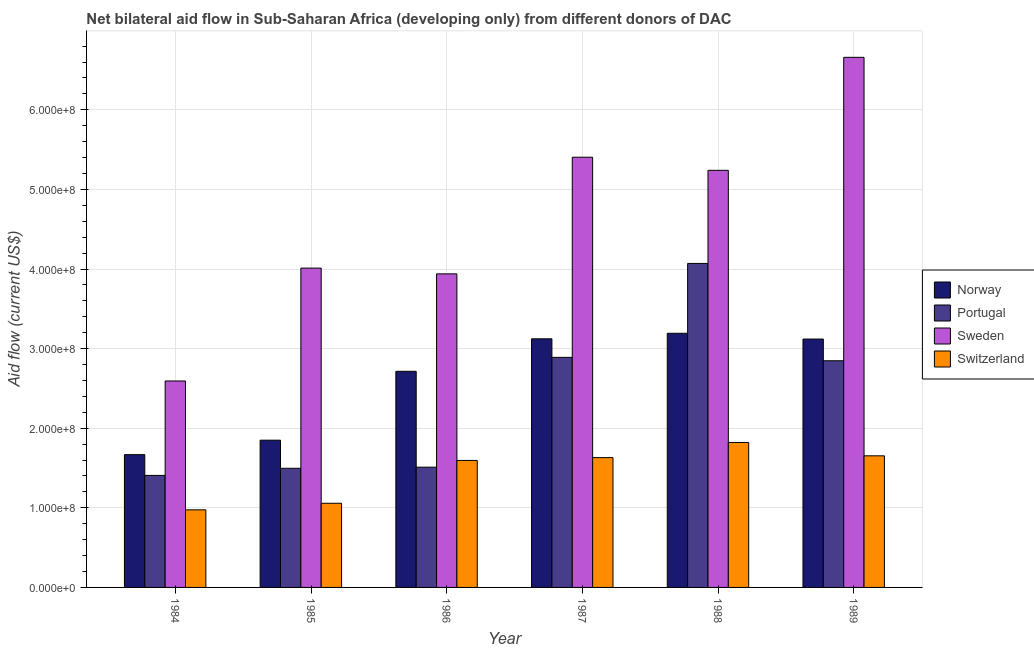How many different coloured bars are there?
Keep it short and to the point. 4. How many groups of bars are there?
Offer a very short reply. 6. Are the number of bars per tick equal to the number of legend labels?
Ensure brevity in your answer.  Yes. Are the number of bars on each tick of the X-axis equal?
Give a very brief answer. Yes. How many bars are there on the 6th tick from the left?
Provide a short and direct response. 4. What is the label of the 1st group of bars from the left?
Offer a very short reply. 1984. What is the amount of aid given by portugal in 1989?
Offer a terse response. 2.85e+08. Across all years, what is the maximum amount of aid given by portugal?
Offer a terse response. 4.07e+08. Across all years, what is the minimum amount of aid given by switzerland?
Your answer should be very brief. 9.75e+07. In which year was the amount of aid given by sweden minimum?
Keep it short and to the point. 1984. What is the total amount of aid given by portugal in the graph?
Ensure brevity in your answer.  1.42e+09. What is the difference between the amount of aid given by portugal in 1984 and that in 1988?
Offer a terse response. -2.66e+08. What is the difference between the amount of aid given by sweden in 1989 and the amount of aid given by switzerland in 1984?
Keep it short and to the point. 4.07e+08. What is the average amount of aid given by switzerland per year?
Provide a short and direct response. 1.46e+08. In the year 1986, what is the difference between the amount of aid given by sweden and amount of aid given by switzerland?
Give a very brief answer. 0. What is the ratio of the amount of aid given by switzerland in 1985 to that in 1988?
Your response must be concise. 0.58. What is the difference between the highest and the second highest amount of aid given by norway?
Make the answer very short. 6.95e+06. What is the difference between the highest and the lowest amount of aid given by norway?
Your answer should be compact. 1.52e+08. In how many years, is the amount of aid given by sweden greater than the average amount of aid given by sweden taken over all years?
Your answer should be compact. 3. Is the sum of the amount of aid given by norway in 1984 and 1989 greater than the maximum amount of aid given by switzerland across all years?
Keep it short and to the point. Yes. Is it the case that in every year, the sum of the amount of aid given by sweden and amount of aid given by portugal is greater than the sum of amount of aid given by norway and amount of aid given by switzerland?
Your answer should be compact. Yes. What does the 4th bar from the left in 1989 represents?
Your answer should be compact. Switzerland. What does the 4th bar from the right in 1988 represents?
Your answer should be compact. Norway. Is it the case that in every year, the sum of the amount of aid given by norway and amount of aid given by portugal is greater than the amount of aid given by sweden?
Your response must be concise. No. Are all the bars in the graph horizontal?
Your answer should be very brief. No. How many years are there in the graph?
Your answer should be very brief. 6. What is the difference between two consecutive major ticks on the Y-axis?
Your answer should be compact. 1.00e+08. Are the values on the major ticks of Y-axis written in scientific E-notation?
Provide a short and direct response. Yes. Does the graph contain any zero values?
Ensure brevity in your answer.  No. Does the graph contain grids?
Keep it short and to the point. Yes. Where does the legend appear in the graph?
Offer a very short reply. Center right. What is the title of the graph?
Provide a succinct answer. Net bilateral aid flow in Sub-Saharan Africa (developing only) from different donors of DAC. What is the label or title of the X-axis?
Provide a succinct answer. Year. What is the label or title of the Y-axis?
Offer a terse response. Aid flow (current US$). What is the Aid flow (current US$) of Norway in 1984?
Your answer should be compact. 1.67e+08. What is the Aid flow (current US$) of Portugal in 1984?
Your answer should be compact. 1.41e+08. What is the Aid flow (current US$) in Sweden in 1984?
Offer a terse response. 2.59e+08. What is the Aid flow (current US$) in Switzerland in 1984?
Your response must be concise. 9.75e+07. What is the Aid flow (current US$) of Norway in 1985?
Your response must be concise. 1.85e+08. What is the Aid flow (current US$) in Portugal in 1985?
Provide a succinct answer. 1.50e+08. What is the Aid flow (current US$) of Sweden in 1985?
Ensure brevity in your answer.  4.01e+08. What is the Aid flow (current US$) in Switzerland in 1985?
Your answer should be very brief. 1.06e+08. What is the Aid flow (current US$) of Norway in 1986?
Give a very brief answer. 2.72e+08. What is the Aid flow (current US$) of Portugal in 1986?
Your answer should be very brief. 1.51e+08. What is the Aid flow (current US$) of Sweden in 1986?
Ensure brevity in your answer.  3.94e+08. What is the Aid flow (current US$) of Switzerland in 1986?
Ensure brevity in your answer.  1.60e+08. What is the Aid flow (current US$) in Norway in 1987?
Ensure brevity in your answer.  3.12e+08. What is the Aid flow (current US$) of Portugal in 1987?
Make the answer very short. 2.89e+08. What is the Aid flow (current US$) in Sweden in 1987?
Offer a terse response. 5.40e+08. What is the Aid flow (current US$) in Switzerland in 1987?
Your answer should be very brief. 1.63e+08. What is the Aid flow (current US$) in Norway in 1988?
Ensure brevity in your answer.  3.19e+08. What is the Aid flow (current US$) of Portugal in 1988?
Your response must be concise. 4.07e+08. What is the Aid flow (current US$) in Sweden in 1988?
Give a very brief answer. 5.24e+08. What is the Aid flow (current US$) of Switzerland in 1988?
Your response must be concise. 1.82e+08. What is the Aid flow (current US$) of Norway in 1989?
Provide a short and direct response. 3.12e+08. What is the Aid flow (current US$) of Portugal in 1989?
Your answer should be very brief. 2.85e+08. What is the Aid flow (current US$) of Sweden in 1989?
Provide a short and direct response. 6.66e+08. What is the Aid flow (current US$) of Switzerland in 1989?
Make the answer very short. 1.65e+08. Across all years, what is the maximum Aid flow (current US$) of Norway?
Provide a succinct answer. 3.19e+08. Across all years, what is the maximum Aid flow (current US$) in Portugal?
Ensure brevity in your answer.  4.07e+08. Across all years, what is the maximum Aid flow (current US$) in Sweden?
Offer a terse response. 6.66e+08. Across all years, what is the maximum Aid flow (current US$) of Switzerland?
Give a very brief answer. 1.82e+08. Across all years, what is the minimum Aid flow (current US$) of Norway?
Provide a succinct answer. 1.67e+08. Across all years, what is the minimum Aid flow (current US$) of Portugal?
Keep it short and to the point. 1.41e+08. Across all years, what is the minimum Aid flow (current US$) of Sweden?
Provide a short and direct response. 2.59e+08. Across all years, what is the minimum Aid flow (current US$) of Switzerland?
Offer a terse response. 9.75e+07. What is the total Aid flow (current US$) in Norway in the graph?
Provide a short and direct response. 1.57e+09. What is the total Aid flow (current US$) in Portugal in the graph?
Offer a very short reply. 1.42e+09. What is the total Aid flow (current US$) of Sweden in the graph?
Keep it short and to the point. 2.78e+09. What is the total Aid flow (current US$) of Switzerland in the graph?
Your answer should be very brief. 8.73e+08. What is the difference between the Aid flow (current US$) in Norway in 1984 and that in 1985?
Offer a very short reply. -1.82e+07. What is the difference between the Aid flow (current US$) of Portugal in 1984 and that in 1985?
Keep it short and to the point. -8.95e+06. What is the difference between the Aid flow (current US$) in Sweden in 1984 and that in 1985?
Your answer should be very brief. -1.42e+08. What is the difference between the Aid flow (current US$) of Switzerland in 1984 and that in 1985?
Keep it short and to the point. -8.23e+06. What is the difference between the Aid flow (current US$) in Norway in 1984 and that in 1986?
Keep it short and to the point. -1.05e+08. What is the difference between the Aid flow (current US$) in Portugal in 1984 and that in 1986?
Ensure brevity in your answer.  -1.04e+07. What is the difference between the Aid flow (current US$) of Sweden in 1984 and that in 1986?
Your response must be concise. -1.35e+08. What is the difference between the Aid flow (current US$) of Switzerland in 1984 and that in 1986?
Offer a terse response. -6.21e+07. What is the difference between the Aid flow (current US$) in Norway in 1984 and that in 1987?
Offer a terse response. -1.45e+08. What is the difference between the Aid flow (current US$) of Portugal in 1984 and that in 1987?
Offer a very short reply. -1.48e+08. What is the difference between the Aid flow (current US$) of Sweden in 1984 and that in 1987?
Offer a terse response. -2.81e+08. What is the difference between the Aid flow (current US$) in Switzerland in 1984 and that in 1987?
Your answer should be very brief. -6.56e+07. What is the difference between the Aid flow (current US$) in Norway in 1984 and that in 1988?
Offer a very short reply. -1.52e+08. What is the difference between the Aid flow (current US$) in Portugal in 1984 and that in 1988?
Ensure brevity in your answer.  -2.66e+08. What is the difference between the Aid flow (current US$) of Sweden in 1984 and that in 1988?
Ensure brevity in your answer.  -2.65e+08. What is the difference between the Aid flow (current US$) of Switzerland in 1984 and that in 1988?
Offer a very short reply. -8.46e+07. What is the difference between the Aid flow (current US$) of Norway in 1984 and that in 1989?
Offer a very short reply. -1.45e+08. What is the difference between the Aid flow (current US$) of Portugal in 1984 and that in 1989?
Offer a very short reply. -1.44e+08. What is the difference between the Aid flow (current US$) in Sweden in 1984 and that in 1989?
Provide a short and direct response. -4.07e+08. What is the difference between the Aid flow (current US$) of Switzerland in 1984 and that in 1989?
Your response must be concise. -6.78e+07. What is the difference between the Aid flow (current US$) of Norway in 1985 and that in 1986?
Offer a terse response. -8.65e+07. What is the difference between the Aid flow (current US$) in Portugal in 1985 and that in 1986?
Keep it short and to the point. -1.40e+06. What is the difference between the Aid flow (current US$) in Sweden in 1985 and that in 1986?
Your answer should be very brief. 7.24e+06. What is the difference between the Aid flow (current US$) in Switzerland in 1985 and that in 1986?
Ensure brevity in your answer.  -5.38e+07. What is the difference between the Aid flow (current US$) of Norway in 1985 and that in 1987?
Give a very brief answer. -1.27e+08. What is the difference between the Aid flow (current US$) in Portugal in 1985 and that in 1987?
Make the answer very short. -1.39e+08. What is the difference between the Aid flow (current US$) in Sweden in 1985 and that in 1987?
Your answer should be very brief. -1.39e+08. What is the difference between the Aid flow (current US$) in Switzerland in 1985 and that in 1987?
Offer a terse response. -5.74e+07. What is the difference between the Aid flow (current US$) of Norway in 1985 and that in 1988?
Offer a terse response. -1.34e+08. What is the difference between the Aid flow (current US$) of Portugal in 1985 and that in 1988?
Your answer should be compact. -2.57e+08. What is the difference between the Aid flow (current US$) in Sweden in 1985 and that in 1988?
Offer a terse response. -1.23e+08. What is the difference between the Aid flow (current US$) of Switzerland in 1985 and that in 1988?
Provide a succinct answer. -7.64e+07. What is the difference between the Aid flow (current US$) in Norway in 1985 and that in 1989?
Your answer should be compact. -1.27e+08. What is the difference between the Aid flow (current US$) in Portugal in 1985 and that in 1989?
Offer a very short reply. -1.35e+08. What is the difference between the Aid flow (current US$) in Sweden in 1985 and that in 1989?
Provide a succinct answer. -2.65e+08. What is the difference between the Aid flow (current US$) of Switzerland in 1985 and that in 1989?
Your answer should be very brief. -5.96e+07. What is the difference between the Aid flow (current US$) in Norway in 1986 and that in 1987?
Your answer should be very brief. -4.08e+07. What is the difference between the Aid flow (current US$) in Portugal in 1986 and that in 1987?
Keep it short and to the point. -1.38e+08. What is the difference between the Aid flow (current US$) of Sweden in 1986 and that in 1987?
Provide a succinct answer. -1.47e+08. What is the difference between the Aid flow (current US$) in Switzerland in 1986 and that in 1987?
Your response must be concise. -3.52e+06. What is the difference between the Aid flow (current US$) in Norway in 1986 and that in 1988?
Your answer should be compact. -4.78e+07. What is the difference between the Aid flow (current US$) in Portugal in 1986 and that in 1988?
Ensure brevity in your answer.  -2.56e+08. What is the difference between the Aid flow (current US$) of Sweden in 1986 and that in 1988?
Your response must be concise. -1.30e+08. What is the difference between the Aid flow (current US$) of Switzerland in 1986 and that in 1988?
Provide a succinct answer. -2.26e+07. What is the difference between the Aid flow (current US$) of Norway in 1986 and that in 1989?
Ensure brevity in your answer.  -4.05e+07. What is the difference between the Aid flow (current US$) in Portugal in 1986 and that in 1989?
Offer a terse response. -1.34e+08. What is the difference between the Aid flow (current US$) of Sweden in 1986 and that in 1989?
Your response must be concise. -2.72e+08. What is the difference between the Aid flow (current US$) of Switzerland in 1986 and that in 1989?
Provide a short and direct response. -5.78e+06. What is the difference between the Aid flow (current US$) in Norway in 1987 and that in 1988?
Offer a very short reply. -6.95e+06. What is the difference between the Aid flow (current US$) in Portugal in 1987 and that in 1988?
Offer a very short reply. -1.18e+08. What is the difference between the Aid flow (current US$) in Sweden in 1987 and that in 1988?
Your answer should be very brief. 1.65e+07. What is the difference between the Aid flow (current US$) of Switzerland in 1987 and that in 1988?
Your response must be concise. -1.90e+07. What is the difference between the Aid flow (current US$) of Norway in 1987 and that in 1989?
Your answer should be compact. 2.90e+05. What is the difference between the Aid flow (current US$) in Portugal in 1987 and that in 1989?
Make the answer very short. 4.27e+06. What is the difference between the Aid flow (current US$) in Sweden in 1987 and that in 1989?
Your answer should be very brief. -1.26e+08. What is the difference between the Aid flow (current US$) of Switzerland in 1987 and that in 1989?
Keep it short and to the point. -2.26e+06. What is the difference between the Aid flow (current US$) of Norway in 1988 and that in 1989?
Provide a succinct answer. 7.24e+06. What is the difference between the Aid flow (current US$) in Portugal in 1988 and that in 1989?
Offer a very short reply. 1.22e+08. What is the difference between the Aid flow (current US$) of Sweden in 1988 and that in 1989?
Make the answer very short. -1.42e+08. What is the difference between the Aid flow (current US$) of Switzerland in 1988 and that in 1989?
Give a very brief answer. 1.68e+07. What is the difference between the Aid flow (current US$) in Norway in 1984 and the Aid flow (current US$) in Portugal in 1985?
Your response must be concise. 1.72e+07. What is the difference between the Aid flow (current US$) of Norway in 1984 and the Aid flow (current US$) of Sweden in 1985?
Your answer should be very brief. -2.34e+08. What is the difference between the Aid flow (current US$) in Norway in 1984 and the Aid flow (current US$) in Switzerland in 1985?
Make the answer very short. 6.11e+07. What is the difference between the Aid flow (current US$) in Portugal in 1984 and the Aid flow (current US$) in Sweden in 1985?
Provide a short and direct response. -2.60e+08. What is the difference between the Aid flow (current US$) of Portugal in 1984 and the Aid flow (current US$) of Switzerland in 1985?
Provide a short and direct response. 3.50e+07. What is the difference between the Aid flow (current US$) of Sweden in 1984 and the Aid flow (current US$) of Switzerland in 1985?
Your answer should be very brief. 1.54e+08. What is the difference between the Aid flow (current US$) of Norway in 1984 and the Aid flow (current US$) of Portugal in 1986?
Give a very brief answer. 1.58e+07. What is the difference between the Aid flow (current US$) in Norway in 1984 and the Aid flow (current US$) in Sweden in 1986?
Give a very brief answer. -2.27e+08. What is the difference between the Aid flow (current US$) in Norway in 1984 and the Aid flow (current US$) in Switzerland in 1986?
Ensure brevity in your answer.  7.28e+06. What is the difference between the Aid flow (current US$) in Portugal in 1984 and the Aid flow (current US$) in Sweden in 1986?
Your answer should be compact. -2.53e+08. What is the difference between the Aid flow (current US$) in Portugal in 1984 and the Aid flow (current US$) in Switzerland in 1986?
Your answer should be very brief. -1.88e+07. What is the difference between the Aid flow (current US$) in Sweden in 1984 and the Aid flow (current US$) in Switzerland in 1986?
Provide a short and direct response. 9.98e+07. What is the difference between the Aid flow (current US$) in Norway in 1984 and the Aid flow (current US$) in Portugal in 1987?
Offer a very short reply. -1.22e+08. What is the difference between the Aid flow (current US$) of Norway in 1984 and the Aid flow (current US$) of Sweden in 1987?
Keep it short and to the point. -3.74e+08. What is the difference between the Aid flow (current US$) in Norway in 1984 and the Aid flow (current US$) in Switzerland in 1987?
Provide a short and direct response. 3.76e+06. What is the difference between the Aid flow (current US$) of Portugal in 1984 and the Aid flow (current US$) of Sweden in 1987?
Keep it short and to the point. -4.00e+08. What is the difference between the Aid flow (current US$) of Portugal in 1984 and the Aid flow (current US$) of Switzerland in 1987?
Your answer should be compact. -2.24e+07. What is the difference between the Aid flow (current US$) of Sweden in 1984 and the Aid flow (current US$) of Switzerland in 1987?
Provide a succinct answer. 9.63e+07. What is the difference between the Aid flow (current US$) of Norway in 1984 and the Aid flow (current US$) of Portugal in 1988?
Your answer should be very brief. -2.40e+08. What is the difference between the Aid flow (current US$) in Norway in 1984 and the Aid flow (current US$) in Sweden in 1988?
Give a very brief answer. -3.57e+08. What is the difference between the Aid flow (current US$) of Norway in 1984 and the Aid flow (current US$) of Switzerland in 1988?
Offer a terse response. -1.53e+07. What is the difference between the Aid flow (current US$) of Portugal in 1984 and the Aid flow (current US$) of Sweden in 1988?
Offer a very short reply. -3.83e+08. What is the difference between the Aid flow (current US$) of Portugal in 1984 and the Aid flow (current US$) of Switzerland in 1988?
Make the answer very short. -4.14e+07. What is the difference between the Aid flow (current US$) of Sweden in 1984 and the Aid flow (current US$) of Switzerland in 1988?
Give a very brief answer. 7.72e+07. What is the difference between the Aid flow (current US$) of Norway in 1984 and the Aid flow (current US$) of Portugal in 1989?
Offer a very short reply. -1.18e+08. What is the difference between the Aid flow (current US$) of Norway in 1984 and the Aid flow (current US$) of Sweden in 1989?
Ensure brevity in your answer.  -4.99e+08. What is the difference between the Aid flow (current US$) of Norway in 1984 and the Aid flow (current US$) of Switzerland in 1989?
Offer a very short reply. 1.50e+06. What is the difference between the Aid flow (current US$) of Portugal in 1984 and the Aid flow (current US$) of Sweden in 1989?
Your response must be concise. -5.25e+08. What is the difference between the Aid flow (current US$) of Portugal in 1984 and the Aid flow (current US$) of Switzerland in 1989?
Offer a terse response. -2.46e+07. What is the difference between the Aid flow (current US$) of Sweden in 1984 and the Aid flow (current US$) of Switzerland in 1989?
Your response must be concise. 9.40e+07. What is the difference between the Aid flow (current US$) of Norway in 1985 and the Aid flow (current US$) of Portugal in 1986?
Your answer should be very brief. 3.39e+07. What is the difference between the Aid flow (current US$) in Norway in 1985 and the Aid flow (current US$) in Sweden in 1986?
Ensure brevity in your answer.  -2.09e+08. What is the difference between the Aid flow (current US$) of Norway in 1985 and the Aid flow (current US$) of Switzerland in 1986?
Your answer should be very brief. 2.54e+07. What is the difference between the Aid flow (current US$) in Portugal in 1985 and the Aid flow (current US$) in Sweden in 1986?
Offer a terse response. -2.44e+08. What is the difference between the Aid flow (current US$) of Portugal in 1985 and the Aid flow (current US$) of Switzerland in 1986?
Your answer should be compact. -9.88e+06. What is the difference between the Aid flow (current US$) of Sweden in 1985 and the Aid flow (current US$) of Switzerland in 1986?
Give a very brief answer. 2.42e+08. What is the difference between the Aid flow (current US$) in Norway in 1985 and the Aid flow (current US$) in Portugal in 1987?
Ensure brevity in your answer.  -1.04e+08. What is the difference between the Aid flow (current US$) of Norway in 1985 and the Aid flow (current US$) of Sweden in 1987?
Your answer should be very brief. -3.55e+08. What is the difference between the Aid flow (current US$) of Norway in 1985 and the Aid flow (current US$) of Switzerland in 1987?
Your response must be concise. 2.19e+07. What is the difference between the Aid flow (current US$) in Portugal in 1985 and the Aid flow (current US$) in Sweden in 1987?
Offer a very short reply. -3.91e+08. What is the difference between the Aid flow (current US$) of Portugal in 1985 and the Aid flow (current US$) of Switzerland in 1987?
Your response must be concise. -1.34e+07. What is the difference between the Aid flow (current US$) in Sweden in 1985 and the Aid flow (current US$) in Switzerland in 1987?
Ensure brevity in your answer.  2.38e+08. What is the difference between the Aid flow (current US$) of Norway in 1985 and the Aid flow (current US$) of Portugal in 1988?
Provide a short and direct response. -2.22e+08. What is the difference between the Aid flow (current US$) of Norway in 1985 and the Aid flow (current US$) of Sweden in 1988?
Your answer should be very brief. -3.39e+08. What is the difference between the Aid flow (current US$) of Norway in 1985 and the Aid flow (current US$) of Switzerland in 1988?
Your answer should be very brief. 2.89e+06. What is the difference between the Aid flow (current US$) of Portugal in 1985 and the Aid flow (current US$) of Sweden in 1988?
Your answer should be very brief. -3.74e+08. What is the difference between the Aid flow (current US$) in Portugal in 1985 and the Aid flow (current US$) in Switzerland in 1988?
Provide a short and direct response. -3.24e+07. What is the difference between the Aid flow (current US$) in Sweden in 1985 and the Aid flow (current US$) in Switzerland in 1988?
Keep it short and to the point. 2.19e+08. What is the difference between the Aid flow (current US$) of Norway in 1985 and the Aid flow (current US$) of Portugal in 1989?
Ensure brevity in your answer.  -9.98e+07. What is the difference between the Aid flow (current US$) of Norway in 1985 and the Aid flow (current US$) of Sweden in 1989?
Provide a succinct answer. -4.81e+08. What is the difference between the Aid flow (current US$) in Norway in 1985 and the Aid flow (current US$) in Switzerland in 1989?
Ensure brevity in your answer.  1.97e+07. What is the difference between the Aid flow (current US$) of Portugal in 1985 and the Aid flow (current US$) of Sweden in 1989?
Offer a terse response. -5.16e+08. What is the difference between the Aid flow (current US$) in Portugal in 1985 and the Aid flow (current US$) in Switzerland in 1989?
Your answer should be very brief. -1.57e+07. What is the difference between the Aid flow (current US$) in Sweden in 1985 and the Aid flow (current US$) in Switzerland in 1989?
Your answer should be compact. 2.36e+08. What is the difference between the Aid flow (current US$) in Norway in 1986 and the Aid flow (current US$) in Portugal in 1987?
Ensure brevity in your answer.  -1.75e+07. What is the difference between the Aid flow (current US$) of Norway in 1986 and the Aid flow (current US$) of Sweden in 1987?
Keep it short and to the point. -2.69e+08. What is the difference between the Aid flow (current US$) in Norway in 1986 and the Aid flow (current US$) in Switzerland in 1987?
Ensure brevity in your answer.  1.08e+08. What is the difference between the Aid flow (current US$) in Portugal in 1986 and the Aid flow (current US$) in Sweden in 1987?
Your answer should be very brief. -3.89e+08. What is the difference between the Aid flow (current US$) of Portugal in 1986 and the Aid flow (current US$) of Switzerland in 1987?
Your response must be concise. -1.20e+07. What is the difference between the Aid flow (current US$) in Sweden in 1986 and the Aid flow (current US$) in Switzerland in 1987?
Make the answer very short. 2.31e+08. What is the difference between the Aid flow (current US$) in Norway in 1986 and the Aid flow (current US$) in Portugal in 1988?
Keep it short and to the point. -1.36e+08. What is the difference between the Aid flow (current US$) in Norway in 1986 and the Aid flow (current US$) in Sweden in 1988?
Provide a succinct answer. -2.52e+08. What is the difference between the Aid flow (current US$) in Norway in 1986 and the Aid flow (current US$) in Switzerland in 1988?
Make the answer very short. 8.94e+07. What is the difference between the Aid flow (current US$) of Portugal in 1986 and the Aid flow (current US$) of Sweden in 1988?
Your answer should be very brief. -3.73e+08. What is the difference between the Aid flow (current US$) in Portugal in 1986 and the Aid flow (current US$) in Switzerland in 1988?
Keep it short and to the point. -3.10e+07. What is the difference between the Aid flow (current US$) in Sweden in 1986 and the Aid flow (current US$) in Switzerland in 1988?
Provide a short and direct response. 2.12e+08. What is the difference between the Aid flow (current US$) of Norway in 1986 and the Aid flow (current US$) of Portugal in 1989?
Your answer should be compact. -1.32e+07. What is the difference between the Aid flow (current US$) in Norway in 1986 and the Aid flow (current US$) in Sweden in 1989?
Offer a very short reply. -3.94e+08. What is the difference between the Aid flow (current US$) in Norway in 1986 and the Aid flow (current US$) in Switzerland in 1989?
Offer a very short reply. 1.06e+08. What is the difference between the Aid flow (current US$) in Portugal in 1986 and the Aid flow (current US$) in Sweden in 1989?
Your answer should be compact. -5.15e+08. What is the difference between the Aid flow (current US$) in Portugal in 1986 and the Aid flow (current US$) in Switzerland in 1989?
Ensure brevity in your answer.  -1.43e+07. What is the difference between the Aid flow (current US$) of Sweden in 1986 and the Aid flow (current US$) of Switzerland in 1989?
Offer a very short reply. 2.29e+08. What is the difference between the Aid flow (current US$) of Norway in 1987 and the Aid flow (current US$) of Portugal in 1988?
Offer a terse response. -9.47e+07. What is the difference between the Aid flow (current US$) of Norway in 1987 and the Aid flow (current US$) of Sweden in 1988?
Give a very brief answer. -2.12e+08. What is the difference between the Aid flow (current US$) in Norway in 1987 and the Aid flow (current US$) in Switzerland in 1988?
Provide a succinct answer. 1.30e+08. What is the difference between the Aid flow (current US$) in Portugal in 1987 and the Aid flow (current US$) in Sweden in 1988?
Your answer should be very brief. -2.35e+08. What is the difference between the Aid flow (current US$) in Portugal in 1987 and the Aid flow (current US$) in Switzerland in 1988?
Offer a very short reply. 1.07e+08. What is the difference between the Aid flow (current US$) of Sweden in 1987 and the Aid flow (current US$) of Switzerland in 1988?
Provide a succinct answer. 3.58e+08. What is the difference between the Aid flow (current US$) in Norway in 1987 and the Aid flow (current US$) in Portugal in 1989?
Your answer should be very brief. 2.76e+07. What is the difference between the Aid flow (current US$) of Norway in 1987 and the Aid flow (current US$) of Sweden in 1989?
Your answer should be very brief. -3.54e+08. What is the difference between the Aid flow (current US$) of Norway in 1987 and the Aid flow (current US$) of Switzerland in 1989?
Offer a very short reply. 1.47e+08. What is the difference between the Aid flow (current US$) in Portugal in 1987 and the Aid flow (current US$) in Sweden in 1989?
Provide a short and direct response. -3.77e+08. What is the difference between the Aid flow (current US$) of Portugal in 1987 and the Aid flow (current US$) of Switzerland in 1989?
Provide a short and direct response. 1.24e+08. What is the difference between the Aid flow (current US$) in Sweden in 1987 and the Aid flow (current US$) in Switzerland in 1989?
Give a very brief answer. 3.75e+08. What is the difference between the Aid flow (current US$) in Norway in 1988 and the Aid flow (current US$) in Portugal in 1989?
Give a very brief answer. 3.45e+07. What is the difference between the Aid flow (current US$) in Norway in 1988 and the Aid flow (current US$) in Sweden in 1989?
Offer a terse response. -3.47e+08. What is the difference between the Aid flow (current US$) in Norway in 1988 and the Aid flow (current US$) in Switzerland in 1989?
Offer a very short reply. 1.54e+08. What is the difference between the Aid flow (current US$) in Portugal in 1988 and the Aid flow (current US$) in Sweden in 1989?
Offer a very short reply. -2.59e+08. What is the difference between the Aid flow (current US$) in Portugal in 1988 and the Aid flow (current US$) in Switzerland in 1989?
Give a very brief answer. 2.42e+08. What is the difference between the Aid flow (current US$) in Sweden in 1988 and the Aid flow (current US$) in Switzerland in 1989?
Keep it short and to the point. 3.59e+08. What is the average Aid flow (current US$) of Norway per year?
Provide a short and direct response. 2.61e+08. What is the average Aid flow (current US$) of Portugal per year?
Keep it short and to the point. 2.37e+08. What is the average Aid flow (current US$) in Sweden per year?
Give a very brief answer. 4.64e+08. What is the average Aid flow (current US$) of Switzerland per year?
Offer a very short reply. 1.46e+08. In the year 1984, what is the difference between the Aid flow (current US$) of Norway and Aid flow (current US$) of Portugal?
Offer a very short reply. 2.61e+07. In the year 1984, what is the difference between the Aid flow (current US$) in Norway and Aid flow (current US$) in Sweden?
Make the answer very short. -9.25e+07. In the year 1984, what is the difference between the Aid flow (current US$) in Norway and Aid flow (current US$) in Switzerland?
Ensure brevity in your answer.  6.94e+07. In the year 1984, what is the difference between the Aid flow (current US$) in Portugal and Aid flow (current US$) in Sweden?
Provide a short and direct response. -1.19e+08. In the year 1984, what is the difference between the Aid flow (current US$) of Portugal and Aid flow (current US$) of Switzerland?
Keep it short and to the point. 4.32e+07. In the year 1984, what is the difference between the Aid flow (current US$) in Sweden and Aid flow (current US$) in Switzerland?
Keep it short and to the point. 1.62e+08. In the year 1985, what is the difference between the Aid flow (current US$) of Norway and Aid flow (current US$) of Portugal?
Provide a succinct answer. 3.53e+07. In the year 1985, what is the difference between the Aid flow (current US$) of Norway and Aid flow (current US$) of Sweden?
Provide a short and direct response. -2.16e+08. In the year 1985, what is the difference between the Aid flow (current US$) of Norway and Aid flow (current US$) of Switzerland?
Provide a short and direct response. 7.93e+07. In the year 1985, what is the difference between the Aid flow (current US$) of Portugal and Aid flow (current US$) of Sweden?
Offer a very short reply. -2.51e+08. In the year 1985, what is the difference between the Aid flow (current US$) in Portugal and Aid flow (current US$) in Switzerland?
Your response must be concise. 4.40e+07. In the year 1985, what is the difference between the Aid flow (current US$) in Sweden and Aid flow (current US$) in Switzerland?
Keep it short and to the point. 2.95e+08. In the year 1986, what is the difference between the Aid flow (current US$) of Norway and Aid flow (current US$) of Portugal?
Make the answer very short. 1.20e+08. In the year 1986, what is the difference between the Aid flow (current US$) of Norway and Aid flow (current US$) of Sweden?
Provide a succinct answer. -1.22e+08. In the year 1986, what is the difference between the Aid flow (current US$) in Norway and Aid flow (current US$) in Switzerland?
Ensure brevity in your answer.  1.12e+08. In the year 1986, what is the difference between the Aid flow (current US$) in Portugal and Aid flow (current US$) in Sweden?
Keep it short and to the point. -2.43e+08. In the year 1986, what is the difference between the Aid flow (current US$) in Portugal and Aid flow (current US$) in Switzerland?
Your response must be concise. -8.48e+06. In the year 1986, what is the difference between the Aid flow (current US$) in Sweden and Aid flow (current US$) in Switzerland?
Your answer should be very brief. 2.34e+08. In the year 1987, what is the difference between the Aid flow (current US$) in Norway and Aid flow (current US$) in Portugal?
Offer a terse response. 2.33e+07. In the year 1987, what is the difference between the Aid flow (current US$) of Norway and Aid flow (current US$) of Sweden?
Your answer should be very brief. -2.28e+08. In the year 1987, what is the difference between the Aid flow (current US$) in Norway and Aid flow (current US$) in Switzerland?
Ensure brevity in your answer.  1.49e+08. In the year 1987, what is the difference between the Aid flow (current US$) of Portugal and Aid flow (current US$) of Sweden?
Give a very brief answer. -2.51e+08. In the year 1987, what is the difference between the Aid flow (current US$) in Portugal and Aid flow (current US$) in Switzerland?
Offer a very short reply. 1.26e+08. In the year 1987, what is the difference between the Aid flow (current US$) in Sweden and Aid flow (current US$) in Switzerland?
Your answer should be compact. 3.77e+08. In the year 1988, what is the difference between the Aid flow (current US$) of Norway and Aid flow (current US$) of Portugal?
Offer a terse response. -8.78e+07. In the year 1988, what is the difference between the Aid flow (current US$) in Norway and Aid flow (current US$) in Sweden?
Offer a terse response. -2.05e+08. In the year 1988, what is the difference between the Aid flow (current US$) in Norway and Aid flow (current US$) in Switzerland?
Ensure brevity in your answer.  1.37e+08. In the year 1988, what is the difference between the Aid flow (current US$) of Portugal and Aid flow (current US$) of Sweden?
Give a very brief answer. -1.17e+08. In the year 1988, what is the difference between the Aid flow (current US$) in Portugal and Aid flow (current US$) in Switzerland?
Give a very brief answer. 2.25e+08. In the year 1988, what is the difference between the Aid flow (current US$) of Sweden and Aid flow (current US$) of Switzerland?
Your answer should be compact. 3.42e+08. In the year 1989, what is the difference between the Aid flow (current US$) of Norway and Aid flow (current US$) of Portugal?
Your response must be concise. 2.73e+07. In the year 1989, what is the difference between the Aid flow (current US$) in Norway and Aid flow (current US$) in Sweden?
Your answer should be very brief. -3.54e+08. In the year 1989, what is the difference between the Aid flow (current US$) in Norway and Aid flow (current US$) in Switzerland?
Provide a short and direct response. 1.47e+08. In the year 1989, what is the difference between the Aid flow (current US$) of Portugal and Aid flow (current US$) of Sweden?
Offer a terse response. -3.81e+08. In the year 1989, what is the difference between the Aid flow (current US$) of Portugal and Aid flow (current US$) of Switzerland?
Keep it short and to the point. 1.19e+08. In the year 1989, what is the difference between the Aid flow (current US$) in Sweden and Aid flow (current US$) in Switzerland?
Your response must be concise. 5.01e+08. What is the ratio of the Aid flow (current US$) of Norway in 1984 to that in 1985?
Ensure brevity in your answer.  0.9. What is the ratio of the Aid flow (current US$) of Portugal in 1984 to that in 1985?
Keep it short and to the point. 0.94. What is the ratio of the Aid flow (current US$) of Sweden in 1984 to that in 1985?
Your answer should be very brief. 0.65. What is the ratio of the Aid flow (current US$) of Switzerland in 1984 to that in 1985?
Provide a succinct answer. 0.92. What is the ratio of the Aid flow (current US$) of Norway in 1984 to that in 1986?
Keep it short and to the point. 0.61. What is the ratio of the Aid flow (current US$) of Portugal in 1984 to that in 1986?
Offer a terse response. 0.93. What is the ratio of the Aid flow (current US$) of Sweden in 1984 to that in 1986?
Ensure brevity in your answer.  0.66. What is the ratio of the Aid flow (current US$) of Switzerland in 1984 to that in 1986?
Your answer should be very brief. 0.61. What is the ratio of the Aid flow (current US$) of Norway in 1984 to that in 1987?
Provide a short and direct response. 0.53. What is the ratio of the Aid flow (current US$) of Portugal in 1984 to that in 1987?
Ensure brevity in your answer.  0.49. What is the ratio of the Aid flow (current US$) in Sweden in 1984 to that in 1987?
Provide a succinct answer. 0.48. What is the ratio of the Aid flow (current US$) in Switzerland in 1984 to that in 1987?
Keep it short and to the point. 0.6. What is the ratio of the Aid flow (current US$) in Norway in 1984 to that in 1988?
Offer a very short reply. 0.52. What is the ratio of the Aid flow (current US$) of Portugal in 1984 to that in 1988?
Ensure brevity in your answer.  0.35. What is the ratio of the Aid flow (current US$) in Sweden in 1984 to that in 1988?
Ensure brevity in your answer.  0.49. What is the ratio of the Aid flow (current US$) of Switzerland in 1984 to that in 1988?
Keep it short and to the point. 0.54. What is the ratio of the Aid flow (current US$) in Norway in 1984 to that in 1989?
Give a very brief answer. 0.53. What is the ratio of the Aid flow (current US$) in Portugal in 1984 to that in 1989?
Provide a succinct answer. 0.49. What is the ratio of the Aid flow (current US$) in Sweden in 1984 to that in 1989?
Give a very brief answer. 0.39. What is the ratio of the Aid flow (current US$) in Switzerland in 1984 to that in 1989?
Provide a short and direct response. 0.59. What is the ratio of the Aid flow (current US$) of Norway in 1985 to that in 1986?
Ensure brevity in your answer.  0.68. What is the ratio of the Aid flow (current US$) in Portugal in 1985 to that in 1986?
Your answer should be very brief. 0.99. What is the ratio of the Aid flow (current US$) of Sweden in 1985 to that in 1986?
Offer a very short reply. 1.02. What is the ratio of the Aid flow (current US$) in Switzerland in 1985 to that in 1986?
Offer a terse response. 0.66. What is the ratio of the Aid flow (current US$) of Norway in 1985 to that in 1987?
Keep it short and to the point. 0.59. What is the ratio of the Aid flow (current US$) in Portugal in 1985 to that in 1987?
Your response must be concise. 0.52. What is the ratio of the Aid flow (current US$) of Sweden in 1985 to that in 1987?
Offer a terse response. 0.74. What is the ratio of the Aid flow (current US$) of Switzerland in 1985 to that in 1987?
Keep it short and to the point. 0.65. What is the ratio of the Aid flow (current US$) in Norway in 1985 to that in 1988?
Offer a terse response. 0.58. What is the ratio of the Aid flow (current US$) of Portugal in 1985 to that in 1988?
Make the answer very short. 0.37. What is the ratio of the Aid flow (current US$) of Sweden in 1985 to that in 1988?
Ensure brevity in your answer.  0.77. What is the ratio of the Aid flow (current US$) in Switzerland in 1985 to that in 1988?
Provide a succinct answer. 0.58. What is the ratio of the Aid flow (current US$) of Norway in 1985 to that in 1989?
Keep it short and to the point. 0.59. What is the ratio of the Aid flow (current US$) in Portugal in 1985 to that in 1989?
Provide a succinct answer. 0.53. What is the ratio of the Aid flow (current US$) in Sweden in 1985 to that in 1989?
Your answer should be very brief. 0.6. What is the ratio of the Aid flow (current US$) of Switzerland in 1985 to that in 1989?
Make the answer very short. 0.64. What is the ratio of the Aid flow (current US$) in Norway in 1986 to that in 1987?
Your response must be concise. 0.87. What is the ratio of the Aid flow (current US$) of Portugal in 1986 to that in 1987?
Your answer should be very brief. 0.52. What is the ratio of the Aid flow (current US$) in Sweden in 1986 to that in 1987?
Your answer should be compact. 0.73. What is the ratio of the Aid flow (current US$) in Switzerland in 1986 to that in 1987?
Make the answer very short. 0.98. What is the ratio of the Aid flow (current US$) in Norway in 1986 to that in 1988?
Your answer should be compact. 0.85. What is the ratio of the Aid flow (current US$) in Portugal in 1986 to that in 1988?
Ensure brevity in your answer.  0.37. What is the ratio of the Aid flow (current US$) in Sweden in 1986 to that in 1988?
Keep it short and to the point. 0.75. What is the ratio of the Aid flow (current US$) of Switzerland in 1986 to that in 1988?
Offer a very short reply. 0.88. What is the ratio of the Aid flow (current US$) in Norway in 1986 to that in 1989?
Provide a succinct answer. 0.87. What is the ratio of the Aid flow (current US$) in Portugal in 1986 to that in 1989?
Offer a very short reply. 0.53. What is the ratio of the Aid flow (current US$) in Sweden in 1986 to that in 1989?
Your answer should be very brief. 0.59. What is the ratio of the Aid flow (current US$) of Norway in 1987 to that in 1988?
Your answer should be very brief. 0.98. What is the ratio of the Aid flow (current US$) of Portugal in 1987 to that in 1988?
Your response must be concise. 0.71. What is the ratio of the Aid flow (current US$) of Sweden in 1987 to that in 1988?
Keep it short and to the point. 1.03. What is the ratio of the Aid flow (current US$) of Switzerland in 1987 to that in 1988?
Provide a succinct answer. 0.9. What is the ratio of the Aid flow (current US$) in Norway in 1987 to that in 1989?
Your response must be concise. 1. What is the ratio of the Aid flow (current US$) of Sweden in 1987 to that in 1989?
Your response must be concise. 0.81. What is the ratio of the Aid flow (current US$) of Switzerland in 1987 to that in 1989?
Make the answer very short. 0.99. What is the ratio of the Aid flow (current US$) of Norway in 1988 to that in 1989?
Your response must be concise. 1.02. What is the ratio of the Aid flow (current US$) in Portugal in 1988 to that in 1989?
Your response must be concise. 1.43. What is the ratio of the Aid flow (current US$) in Sweden in 1988 to that in 1989?
Give a very brief answer. 0.79. What is the ratio of the Aid flow (current US$) in Switzerland in 1988 to that in 1989?
Your response must be concise. 1.1. What is the difference between the highest and the second highest Aid flow (current US$) of Norway?
Your response must be concise. 6.95e+06. What is the difference between the highest and the second highest Aid flow (current US$) of Portugal?
Offer a very short reply. 1.18e+08. What is the difference between the highest and the second highest Aid flow (current US$) in Sweden?
Provide a short and direct response. 1.26e+08. What is the difference between the highest and the second highest Aid flow (current US$) of Switzerland?
Ensure brevity in your answer.  1.68e+07. What is the difference between the highest and the lowest Aid flow (current US$) of Norway?
Your answer should be very brief. 1.52e+08. What is the difference between the highest and the lowest Aid flow (current US$) of Portugal?
Ensure brevity in your answer.  2.66e+08. What is the difference between the highest and the lowest Aid flow (current US$) in Sweden?
Your answer should be compact. 4.07e+08. What is the difference between the highest and the lowest Aid flow (current US$) of Switzerland?
Offer a terse response. 8.46e+07. 